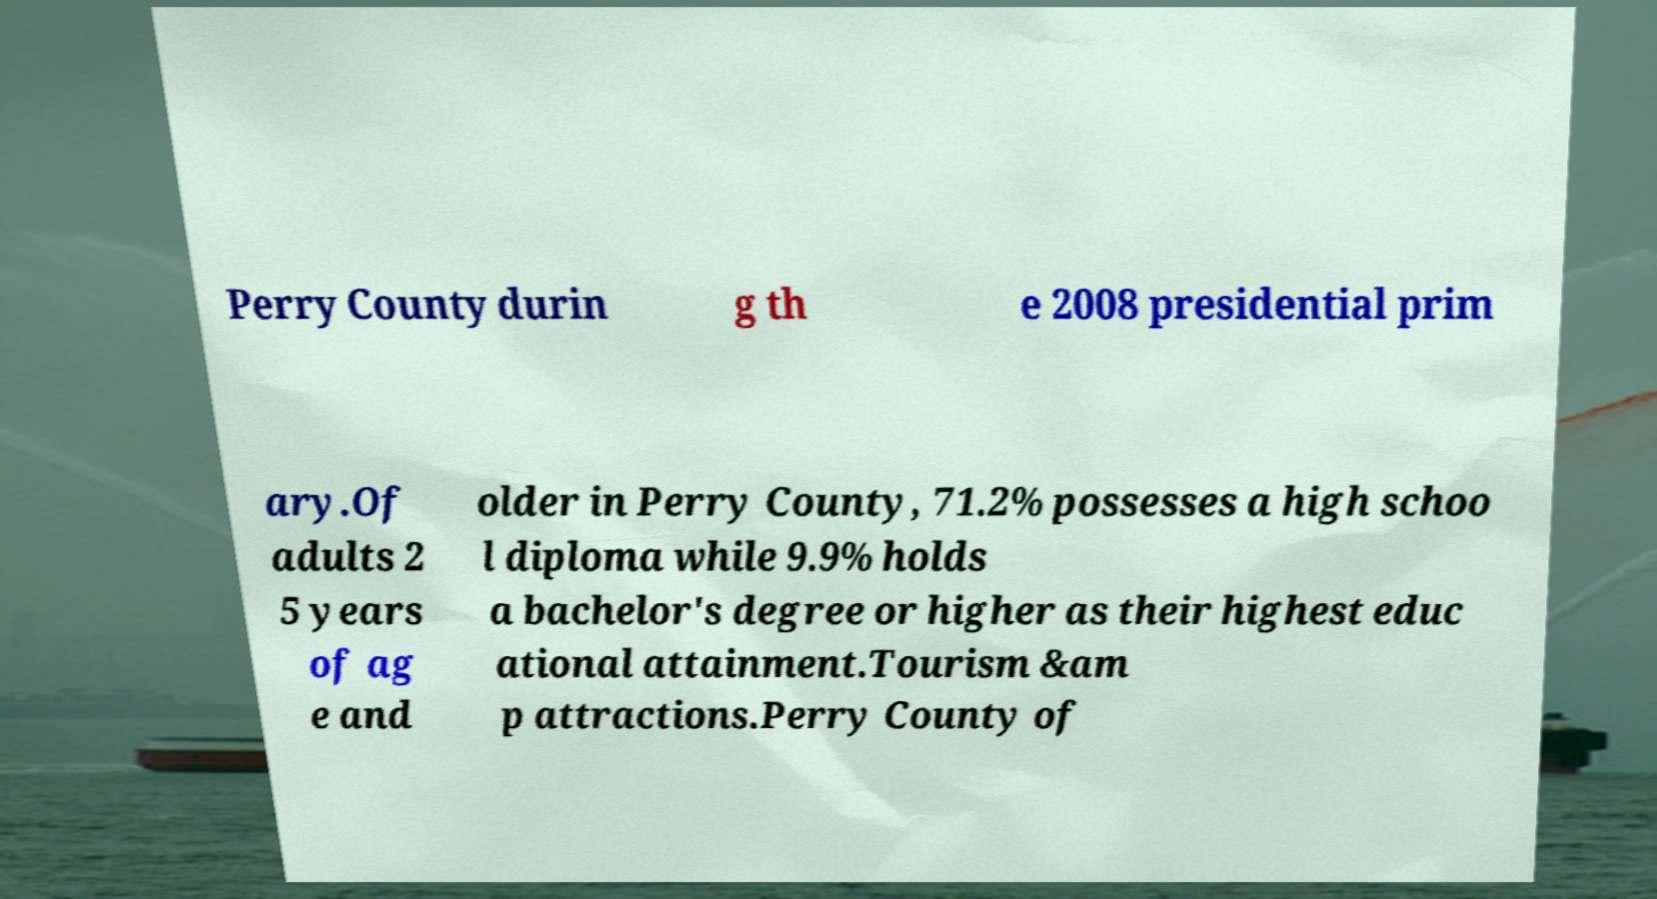I need the written content from this picture converted into text. Can you do that? Perry County durin g th e 2008 presidential prim ary.Of adults 2 5 years of ag e and older in Perry County, 71.2% possesses a high schoo l diploma while 9.9% holds a bachelor's degree or higher as their highest educ ational attainment.Tourism &am p attractions.Perry County of 